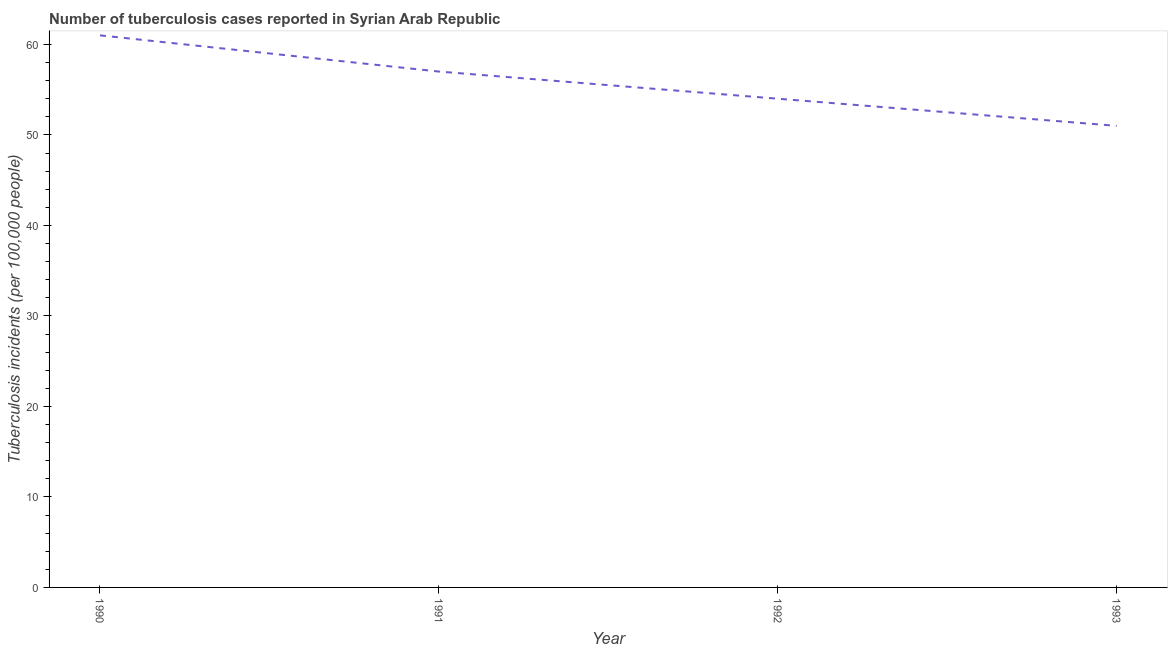What is the number of tuberculosis incidents in 1991?
Your answer should be compact. 57. Across all years, what is the maximum number of tuberculosis incidents?
Your response must be concise. 61. Across all years, what is the minimum number of tuberculosis incidents?
Your response must be concise. 51. In which year was the number of tuberculosis incidents maximum?
Provide a succinct answer. 1990. In which year was the number of tuberculosis incidents minimum?
Offer a very short reply. 1993. What is the sum of the number of tuberculosis incidents?
Offer a very short reply. 223. What is the average number of tuberculosis incidents per year?
Your response must be concise. 55.75. What is the median number of tuberculosis incidents?
Offer a terse response. 55.5. Do a majority of the years between 1993 and 1992 (inclusive) have number of tuberculosis incidents greater than 32 ?
Ensure brevity in your answer.  No. What is the ratio of the number of tuberculosis incidents in 1992 to that in 1993?
Your response must be concise. 1.06. Is the number of tuberculosis incidents in 1990 less than that in 1993?
Give a very brief answer. No. Is the difference between the number of tuberculosis incidents in 1992 and 1993 greater than the difference between any two years?
Your response must be concise. No. What is the difference between the highest and the second highest number of tuberculosis incidents?
Keep it short and to the point. 4. What is the difference between the highest and the lowest number of tuberculosis incidents?
Provide a succinct answer. 10. Does the number of tuberculosis incidents monotonically increase over the years?
Keep it short and to the point. No. What is the difference between two consecutive major ticks on the Y-axis?
Provide a succinct answer. 10. Does the graph contain any zero values?
Your answer should be very brief. No. What is the title of the graph?
Your answer should be very brief. Number of tuberculosis cases reported in Syrian Arab Republic. What is the label or title of the Y-axis?
Provide a succinct answer. Tuberculosis incidents (per 100,0 people). What is the Tuberculosis incidents (per 100,000 people) in 1990?
Keep it short and to the point. 61. What is the Tuberculosis incidents (per 100,000 people) of 1991?
Offer a very short reply. 57. What is the Tuberculosis incidents (per 100,000 people) of 1992?
Ensure brevity in your answer.  54. What is the difference between the Tuberculosis incidents (per 100,000 people) in 1990 and 1991?
Provide a short and direct response. 4. What is the difference between the Tuberculosis incidents (per 100,000 people) in 1990 and 1993?
Provide a short and direct response. 10. What is the difference between the Tuberculosis incidents (per 100,000 people) in 1991 and 1992?
Ensure brevity in your answer.  3. What is the difference between the Tuberculosis incidents (per 100,000 people) in 1992 and 1993?
Make the answer very short. 3. What is the ratio of the Tuberculosis incidents (per 100,000 people) in 1990 to that in 1991?
Provide a short and direct response. 1.07. What is the ratio of the Tuberculosis incidents (per 100,000 people) in 1990 to that in 1992?
Make the answer very short. 1.13. What is the ratio of the Tuberculosis incidents (per 100,000 people) in 1990 to that in 1993?
Make the answer very short. 1.2. What is the ratio of the Tuberculosis incidents (per 100,000 people) in 1991 to that in 1992?
Ensure brevity in your answer.  1.06. What is the ratio of the Tuberculosis incidents (per 100,000 people) in 1991 to that in 1993?
Offer a terse response. 1.12. What is the ratio of the Tuberculosis incidents (per 100,000 people) in 1992 to that in 1993?
Your answer should be compact. 1.06. 